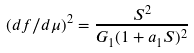Convert formula to latex. <formula><loc_0><loc_0><loc_500><loc_500>( d f / d \mu ) ^ { 2 } = \frac { S ^ { 2 } } { G _ { 1 } ( 1 + a _ { 1 } S ) ^ { 2 } }</formula> 